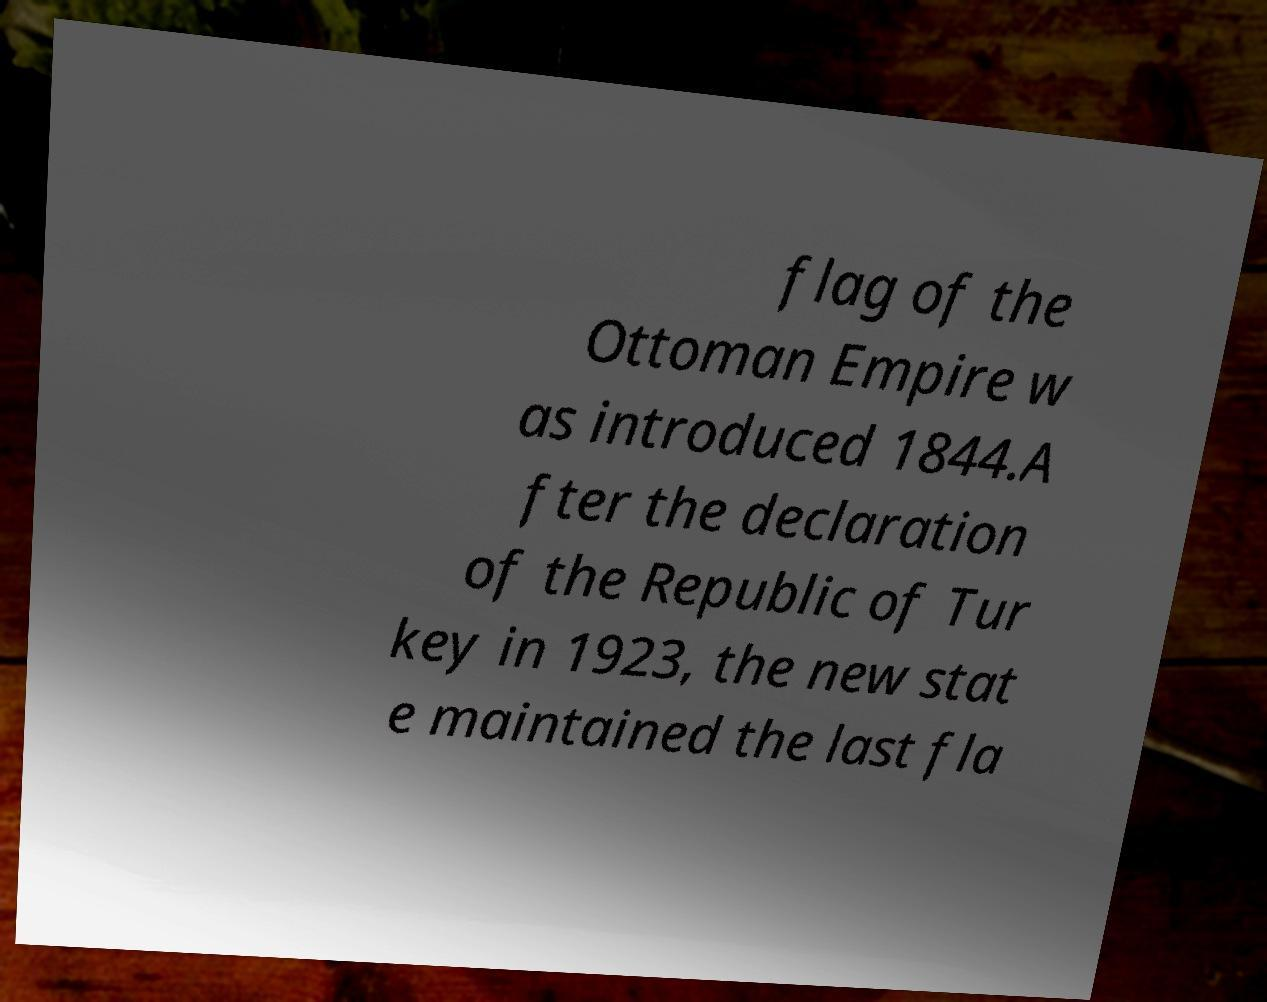Can you read and provide the text displayed in the image?This photo seems to have some interesting text. Can you extract and type it out for me? flag of the Ottoman Empire w as introduced 1844.A fter the declaration of the Republic of Tur key in 1923, the new stat e maintained the last fla 